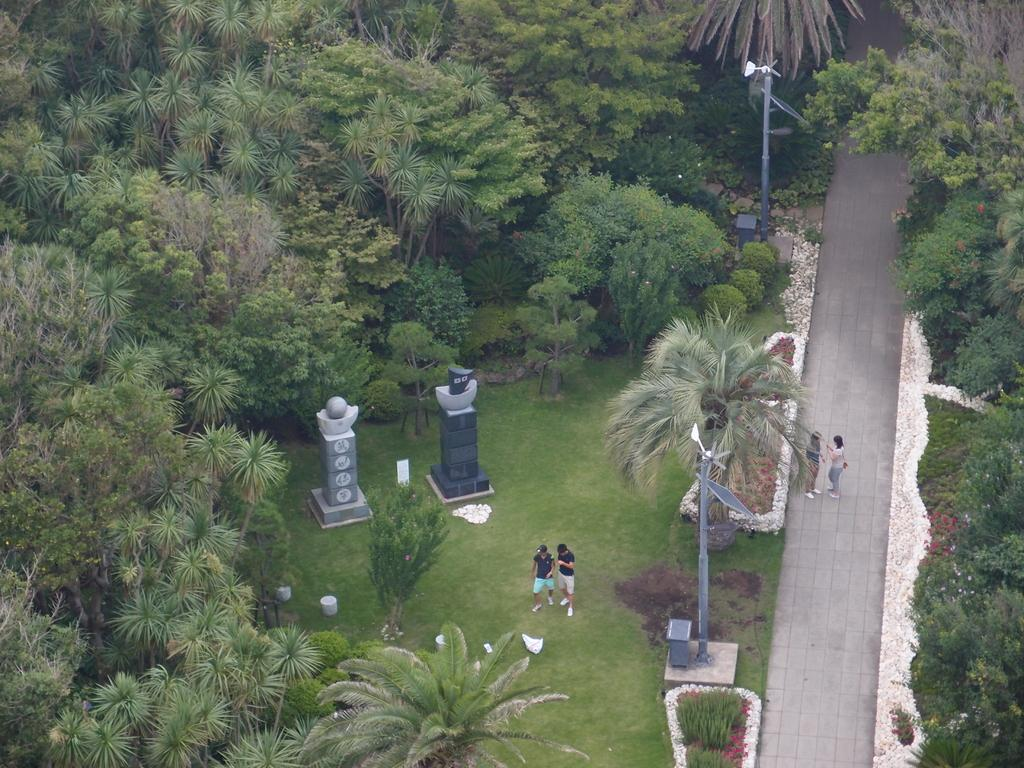What type of vegetation can be seen in the image? There are trees, plants, and grass in the image. What structures are present in the image? There are poles in the image. How many people are in the image? Four persons are standing in the image. What type of vacation are the four persons enjoying in the image? There is no indication of a vacation in the image; it simply shows four persons standing in a setting with trees, plants, grass, and poles. What subject is being taught by the trees in the image? Trees do not teach subjects; they are plants that provide oxygen and shade. 